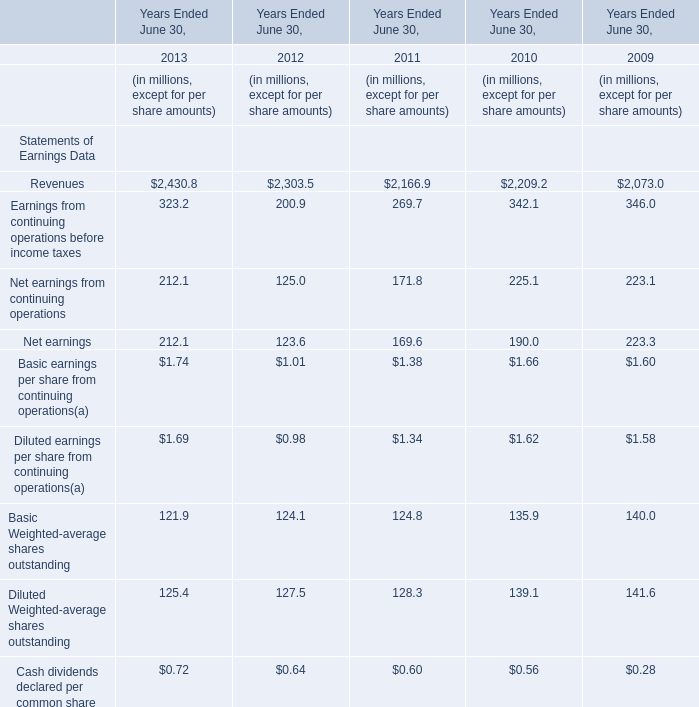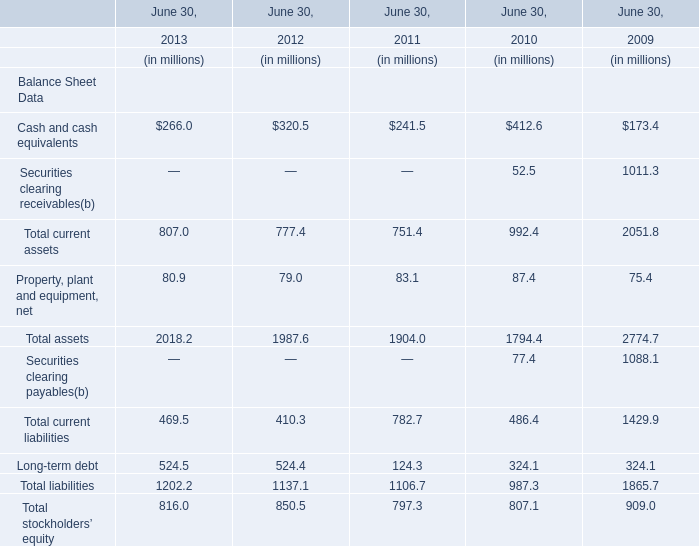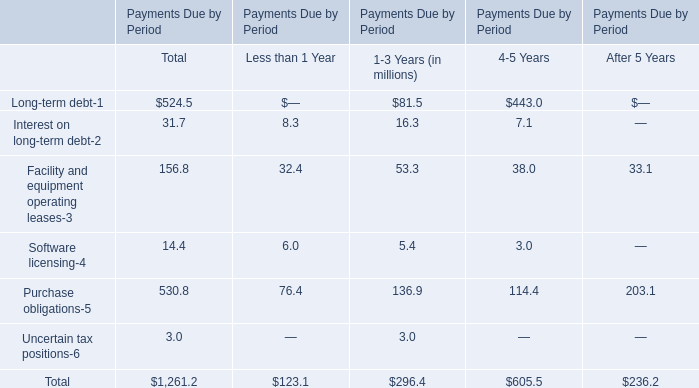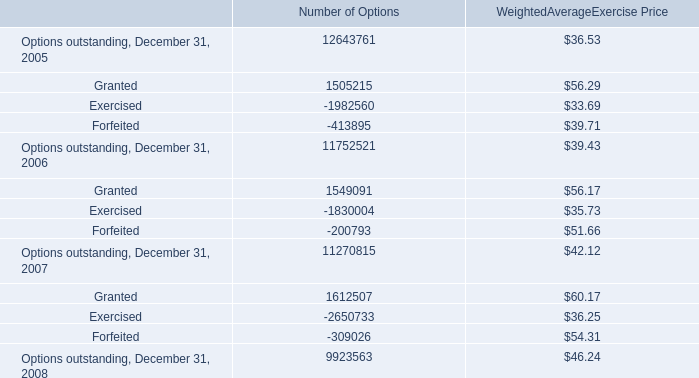What's the difference of Cash and cash equivalents between 2012 and 2013? (in million) 
Computations: (320.5 - 266.0)
Answer: 54.5. 